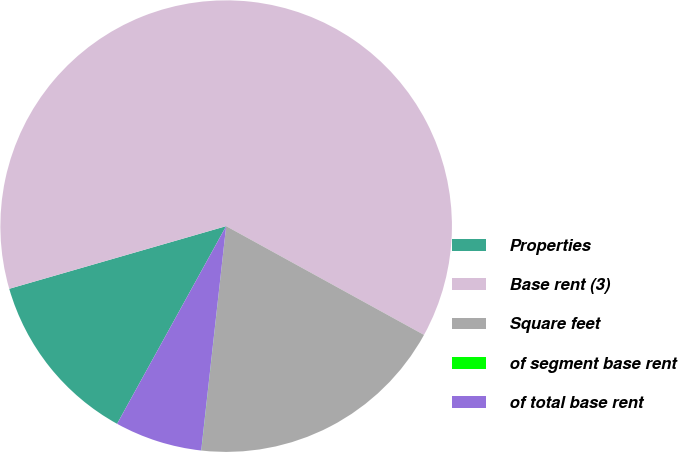<chart> <loc_0><loc_0><loc_500><loc_500><pie_chart><fcel>Properties<fcel>Base rent (3)<fcel>Square feet<fcel>of segment base rent<fcel>of total base rent<nl><fcel>12.5%<fcel>62.47%<fcel>18.75%<fcel>0.01%<fcel>6.26%<nl></chart> 